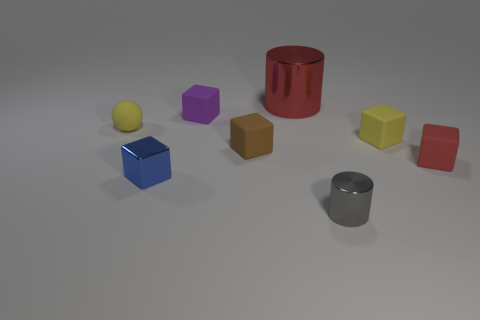Subtract all tiny metal blocks. How many blocks are left? 4 Add 1 red rubber balls. How many objects exist? 9 Subtract all brown cubes. How many cubes are left? 4 Subtract 1 blocks. How many blocks are left? 4 Subtract all green balls. Subtract all purple cylinders. How many balls are left? 1 Subtract all balls. How many objects are left? 7 Subtract 0 green spheres. How many objects are left? 8 Subtract all gray objects. Subtract all brown rubber cubes. How many objects are left? 6 Add 1 yellow rubber blocks. How many yellow rubber blocks are left? 2 Add 7 purple cubes. How many purple cubes exist? 8 